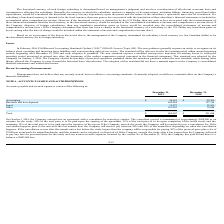According to Protagenic Therapeutics's financial document, What is the quoted consultation fees for the toxicology studies? According to the financial document, $988,000. The relevant text states: "he consultant quoted a commitment of approximately $988,000 as an estimate for the study. 50% of the total price is to be paid upon the signing of the agreement..." Also, What is the company's total accounts payables and accrued expenses as at December 31, 2019? According to the financial document, $865,047. The relevant text states: "Total $ 865,047 $ 231,688..." Also, What is the company's total accounts payables and accrued expenses as at December 31, 2018? According to the financial document, $231,688. The relevant text states: "Total $ 865,047 $ 231,688..." Also, can you calculate: How much did the company pay upon the signing of the toxicology studies agreement? Based on the calculation: 988,000 * 50% , the result is 494000. This is based on the information: "consultant quoted a commitment of approximately $988,000 as an estimate for the study. 50% of the total price is to be paid upon the signing of the agreemen Research and development 650,584 137,114 Re..." The key data points involved are: 50, 988,000. Also, can you calculate: What is the value of accounting related accounts payable as a percentage of the 2019 total accounts payable and accrued expenses? Based on the calculation: 36,161/865,047 , the result is 4.18 (percentage). This is based on the information: "Accounting $ 36,161 $ 52,365 Total $ 865,047 $ 231,688..." The key data points involved are: 36,161, 865,047. Also, can you calculate: What is the percentage change in the accounts payable and accrued expenses between 2018 and 2019? To answer this question, I need to perform calculations using the financial data. The calculation is: (865,047-231,688)/231,688 , which equals 273.37 (percentage). This is based on the information: "Total $ 865,047 $ 231,688 Total $ 865,047 $ 231,688..." The key data points involved are: 231,688, 865,047. 